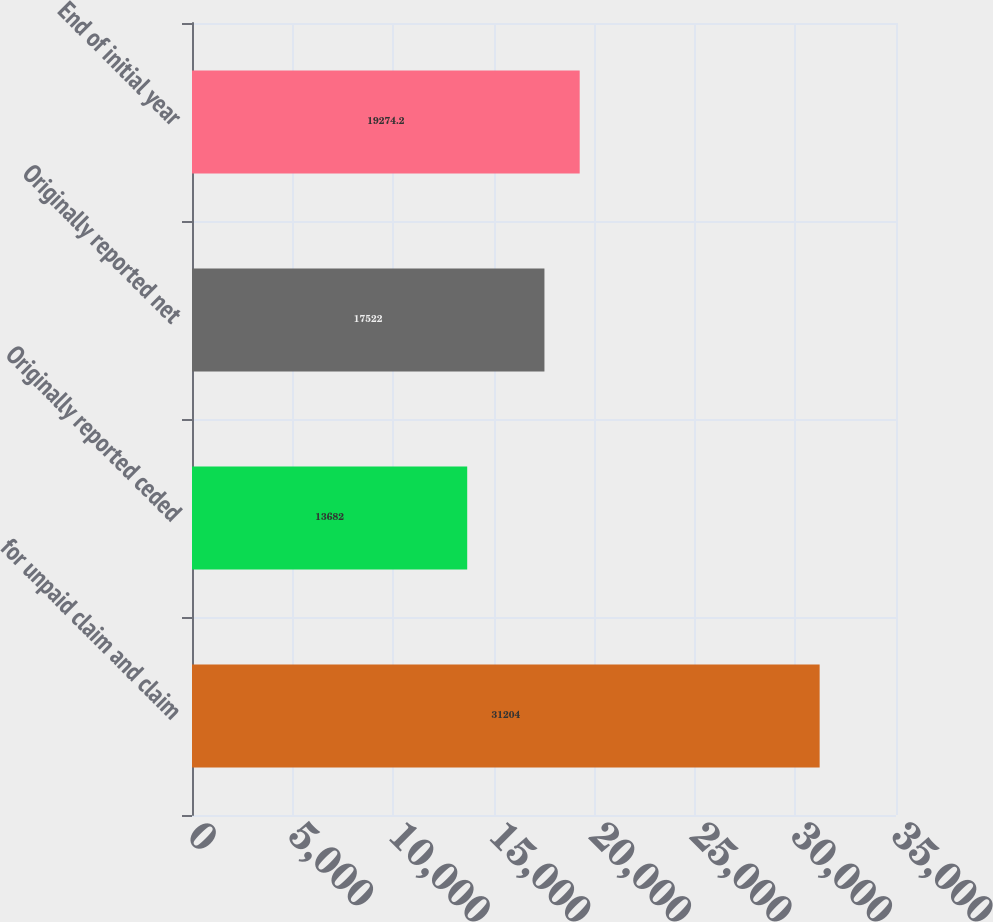Convert chart. <chart><loc_0><loc_0><loc_500><loc_500><bar_chart><fcel>for unpaid claim and claim<fcel>Originally reported ceded<fcel>Originally reported net<fcel>End of initial year<nl><fcel>31204<fcel>13682<fcel>17522<fcel>19274.2<nl></chart> 